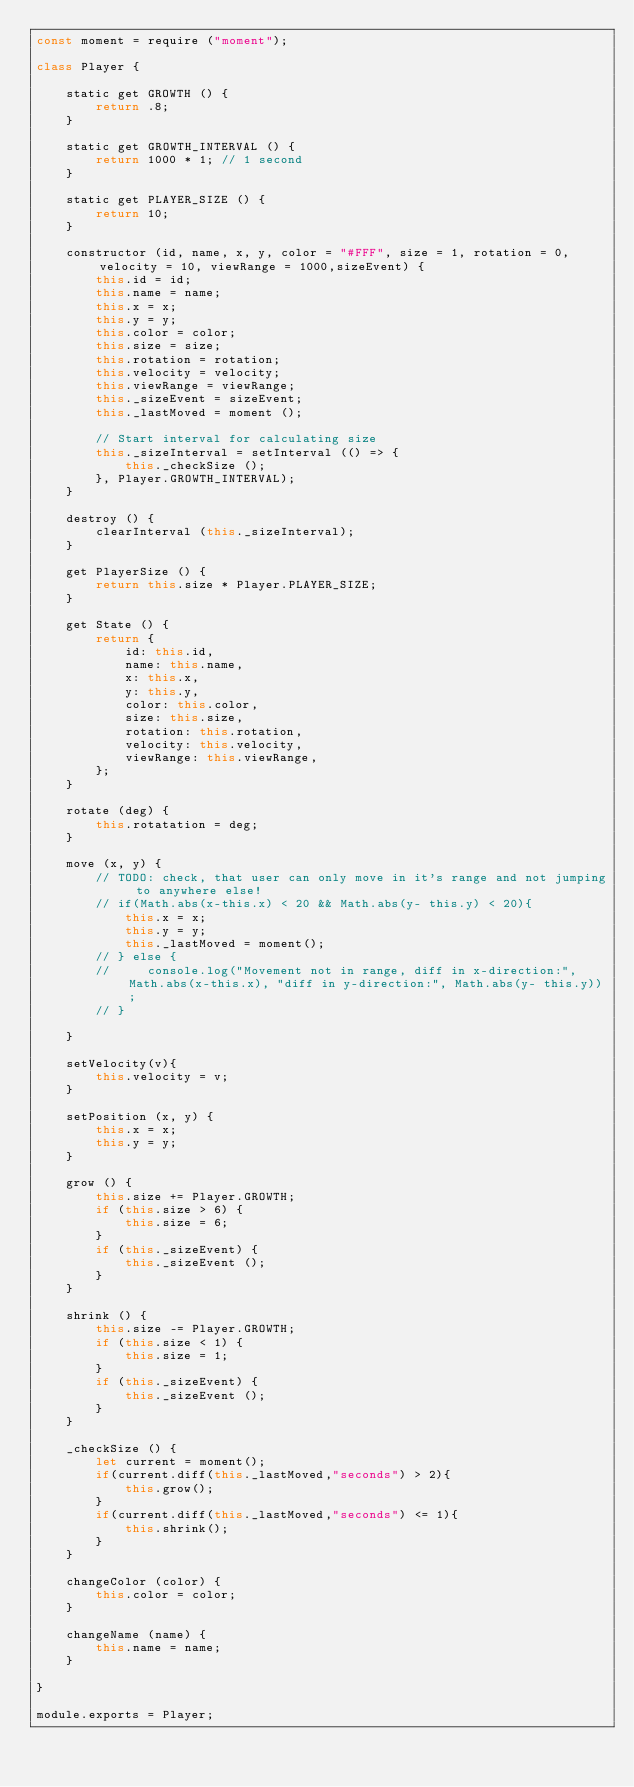Convert code to text. <code><loc_0><loc_0><loc_500><loc_500><_JavaScript_>const moment = require ("moment");

class Player {

    static get GROWTH () {
        return .8;
    }

    static get GROWTH_INTERVAL () {
        return 1000 * 1; // 1 second
    }

    static get PLAYER_SIZE () {
        return 10;
    }

    constructor (id, name, x, y, color = "#FFF", size = 1, rotation = 0, velocity = 10, viewRange = 1000,sizeEvent) {
        this.id = id;
        this.name = name;
        this.x = x;
        this.y = y;
        this.color = color;
        this.size = size;
        this.rotation = rotation;
        this.velocity = velocity;
        this.viewRange = viewRange;
        this._sizeEvent = sizeEvent;
        this._lastMoved = moment ();

        // Start interval for calculating size
        this._sizeInterval = setInterval (() => {
            this._checkSize ();
        }, Player.GROWTH_INTERVAL);
    }

    destroy () {
        clearInterval (this._sizeInterval);
    }

    get PlayerSize () {
        return this.size * Player.PLAYER_SIZE;
    }

    get State () {
        return {
            id: this.id,
            name: this.name,
            x: this.x,
            y: this.y,
            color: this.color,
            size: this.size,
            rotation: this.rotation,
            velocity: this.velocity,
            viewRange: this.viewRange,
        };
    }

    rotate (deg) {
        this.rotatation = deg;
    }

    move (x, y) {
        // TODO: check, that user can only move in it's range and not jumping to anywhere else!
        // if(Math.abs(x-this.x) < 20 && Math.abs(y- this.y) < 20){
            this.x = x;
            this.y = y;
            this._lastMoved = moment();
        // } else {
        //     console.log("Movement not in range, diff in x-direction:", Math.abs(x-this.x), "diff in y-direction:", Math.abs(y- this.y));
        // }

    }

    setVelocity(v){
        this.velocity = v;
    }

    setPosition (x, y) {
        this.x = x;
        this.y = y;
    }

    grow () {
        this.size += Player.GROWTH;
        if (this.size > 6) {
            this.size = 6;
        }
        if (this._sizeEvent) {
            this._sizeEvent ();
        }
    }

    shrink () {
        this.size -= Player.GROWTH;
        if (this.size < 1) {
            this.size = 1;
        }
        if (this._sizeEvent) {
            this._sizeEvent ();
        }
    }

    _checkSize () {
        let current = moment();
        if(current.diff(this._lastMoved,"seconds") > 2){
            this.grow();
        }
        if(current.diff(this._lastMoved,"seconds") <= 1){
            this.shrink();
        }
    }

    changeColor (color) {
        this.color = color;
    }

    changeName (name) {
        this.name = name;
    }

}

module.exports = Player;</code> 